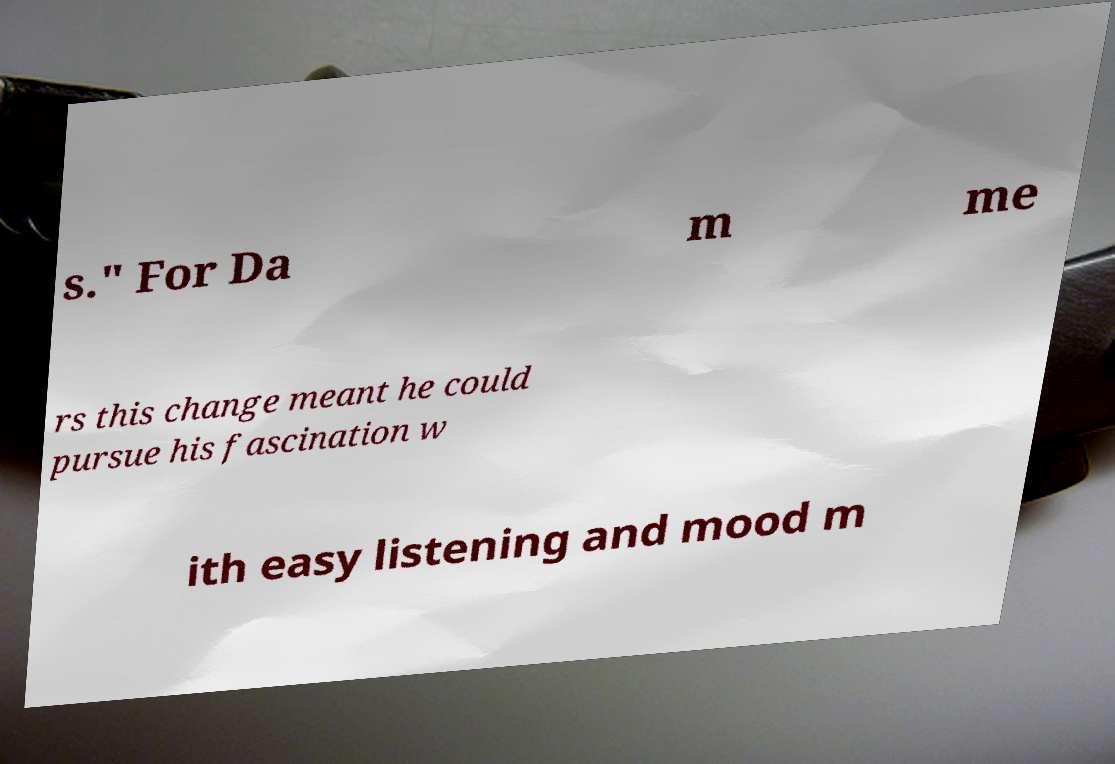Please identify and transcribe the text found in this image. s." For Da m me rs this change meant he could pursue his fascination w ith easy listening and mood m 